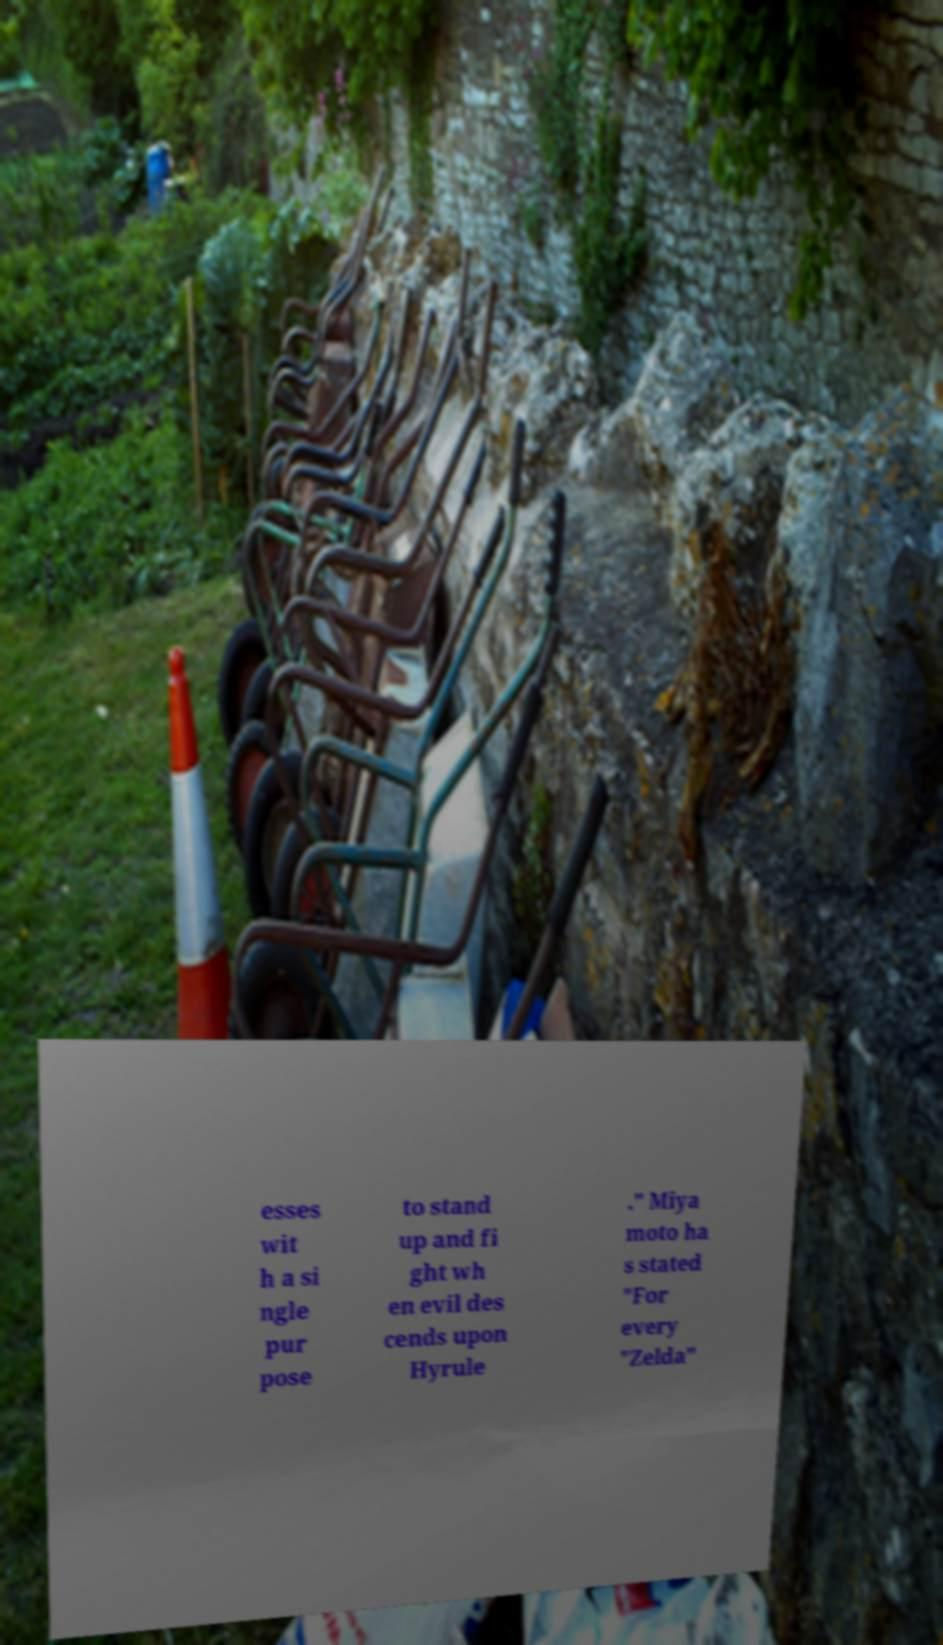Can you accurately transcribe the text from the provided image for me? esses wit h a si ngle pur pose to stand up and fi ght wh en evil des cends upon Hyrule ." Miya moto ha s stated "For every "Zelda" 